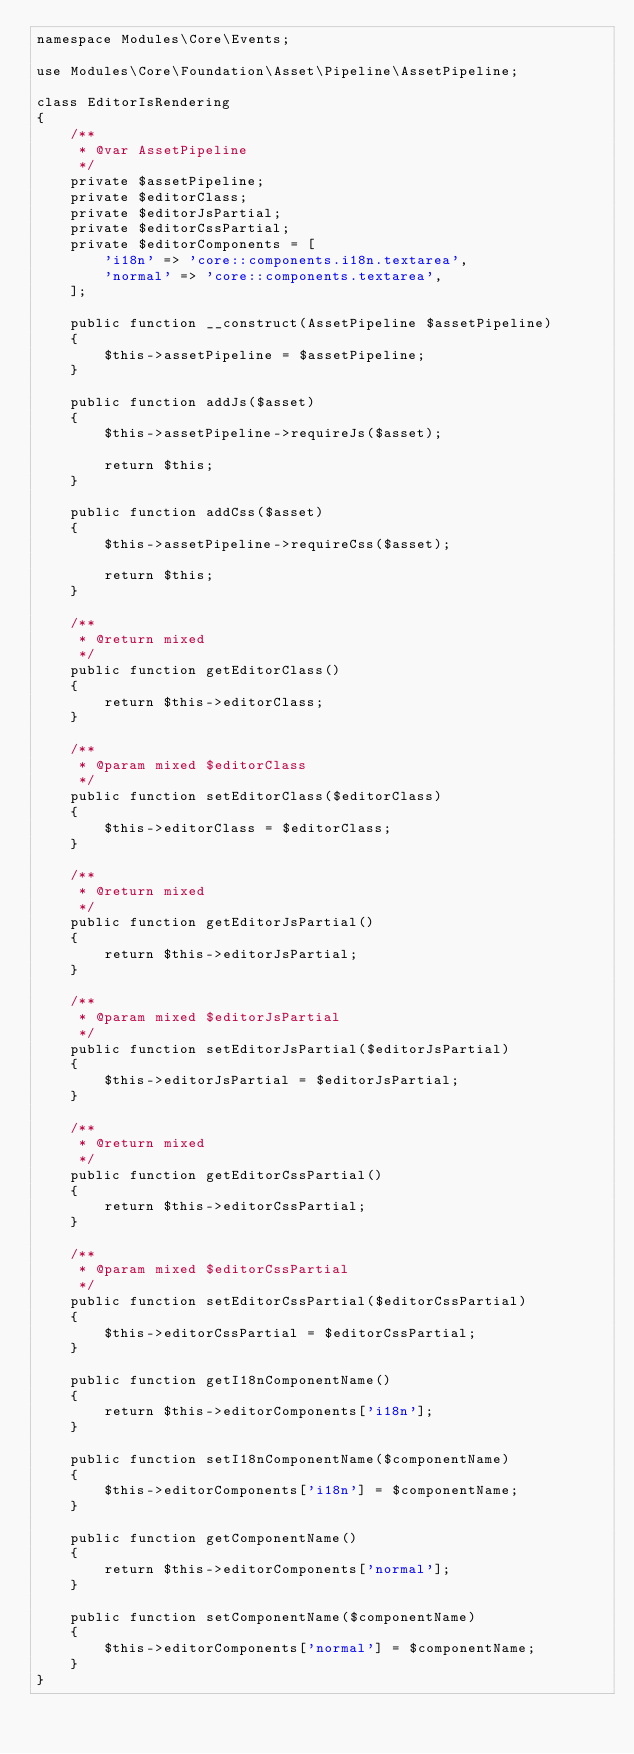Convert code to text. <code><loc_0><loc_0><loc_500><loc_500><_PHP_>namespace Modules\Core\Events;

use Modules\Core\Foundation\Asset\Pipeline\AssetPipeline;

class EditorIsRendering
{
    /**
     * @var AssetPipeline
     */
    private $assetPipeline;
    private $editorClass;
    private $editorJsPartial;
    private $editorCssPartial;
    private $editorComponents = [
        'i18n' => 'core::components.i18n.textarea',
        'normal' => 'core::components.textarea',
    ];

    public function __construct(AssetPipeline $assetPipeline)
    {
        $this->assetPipeline = $assetPipeline;
    }

    public function addJs($asset)
    {
        $this->assetPipeline->requireJs($asset);

        return $this;
    }

    public function addCss($asset)
    {
        $this->assetPipeline->requireCss($asset);

        return $this;
    }

    /**
     * @return mixed
     */
    public function getEditorClass()
    {
        return $this->editorClass;
    }

    /**
     * @param mixed $editorClass
     */
    public function setEditorClass($editorClass)
    {
        $this->editorClass = $editorClass;
    }

    /**
     * @return mixed
     */
    public function getEditorJsPartial()
    {
        return $this->editorJsPartial;
    }

    /**
     * @param mixed $editorJsPartial
     */
    public function setEditorJsPartial($editorJsPartial)
    {
        $this->editorJsPartial = $editorJsPartial;
    }

    /**
     * @return mixed
     */
    public function getEditorCssPartial()
    {
        return $this->editorCssPartial;
    }

    /**
     * @param mixed $editorCssPartial
     */
    public function setEditorCssPartial($editorCssPartial)
    {
        $this->editorCssPartial = $editorCssPartial;
    }

    public function getI18nComponentName()
    {
        return $this->editorComponents['i18n'];
    }

    public function setI18nComponentName($componentName)
    {
        $this->editorComponents['i18n'] = $componentName;
    }

    public function getComponentName()
    {
        return $this->editorComponents['normal'];
    }

    public function setComponentName($componentName)
    {
        $this->editorComponents['normal'] = $componentName;
    }
}</code> 